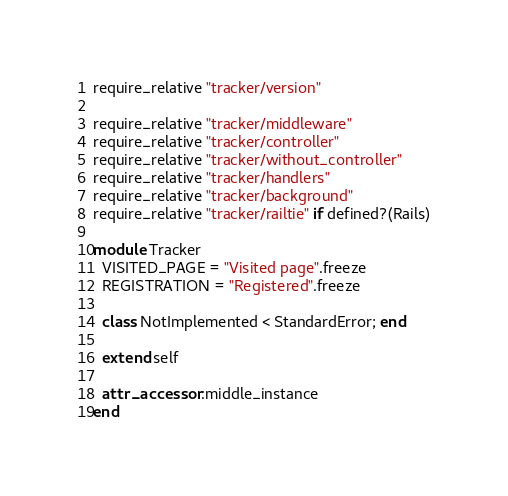<code> <loc_0><loc_0><loc_500><loc_500><_Ruby_>require_relative "tracker/version"

require_relative "tracker/middleware"
require_relative "tracker/controller"
require_relative "tracker/without_controller"
require_relative "tracker/handlers"
require_relative "tracker/background"
require_relative "tracker/railtie" if defined?(Rails)

module Tracker
  VISITED_PAGE = "Visited page".freeze
  REGISTRATION = "Registered".freeze

  class NotImplemented < StandardError; end

  extend self

  attr_accessor :middle_instance
end
</code> 